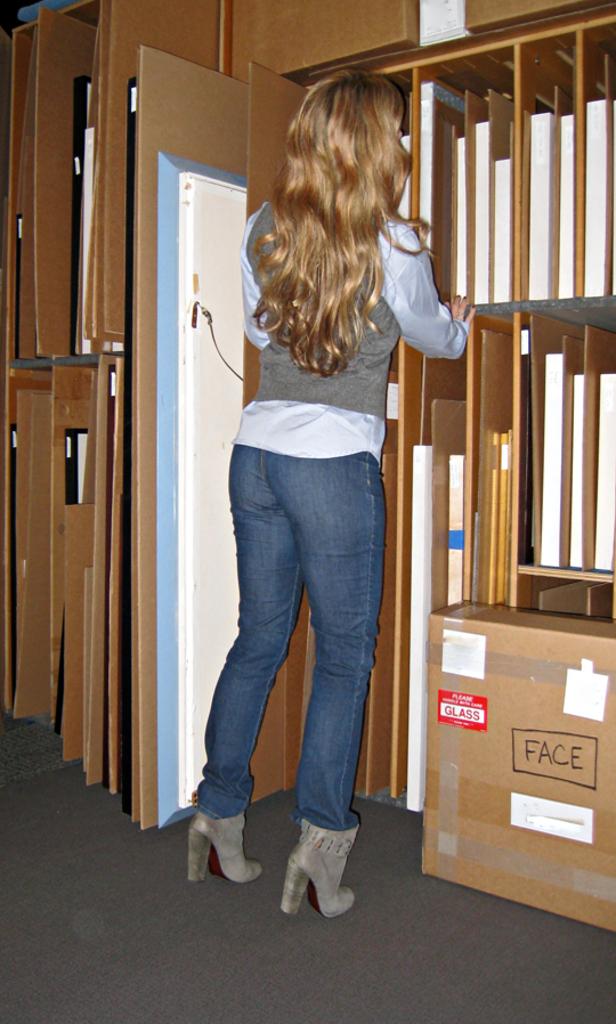What is in the box?
Your answer should be very brief. Face. 